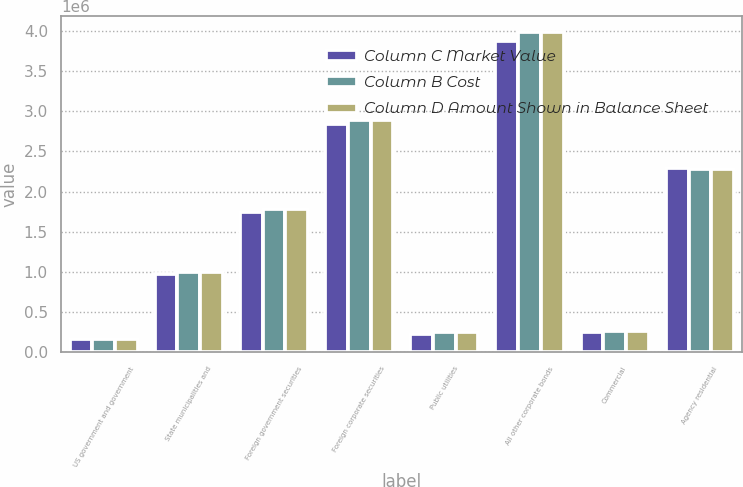<chart> <loc_0><loc_0><loc_500><loc_500><stacked_bar_chart><ecel><fcel>US government and government<fcel>State municipalities and<fcel>Foreign government securities<fcel>Foreign corporate securities<fcel>Public utilities<fcel>All other corporate bonds<fcel>Commercial<fcel>Agency residential<nl><fcel>Column C Market Value<fcel>160013<fcel>970735<fcel>1.74034e+06<fcel>2.84491e+06<fcel>231507<fcel>3.86735e+06<fcel>254765<fcel>2.29472e+06<nl><fcel>Column B Cost<fcel>161025<fcel>1.00253e+06<fcel>1.78077e+06<fcel>2.88581e+06<fcel>248488<fcel>3.98287e+06<fcel>270441<fcel>2.27905e+06<nl><fcel>Column D Amount Shown in Balance Sheet<fcel>161025<fcel>1.00253e+06<fcel>1.78077e+06<fcel>2.88581e+06<fcel>248488<fcel>3.98287e+06<fcel>270441<fcel>2.27905e+06<nl></chart> 